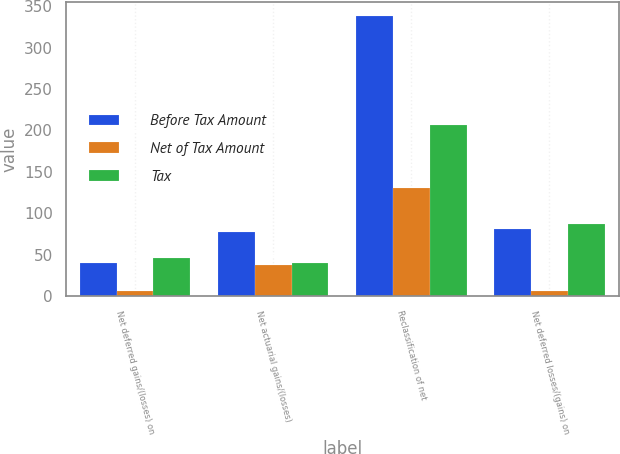Convert chart. <chart><loc_0><loc_0><loc_500><loc_500><stacked_bar_chart><ecel><fcel>Net deferred gains/(losses) on<fcel>Net actuarial gains/(losses)<fcel>Reclassification of net<fcel>Net deferred losses/(gains) on<nl><fcel>Before Tax Amount<fcel>40<fcel>78<fcel>338<fcel>81<nl><fcel>Net of Tax Amount<fcel>6<fcel>38<fcel>131<fcel>6<nl><fcel>Tax<fcel>46<fcel>40<fcel>207<fcel>87<nl></chart> 